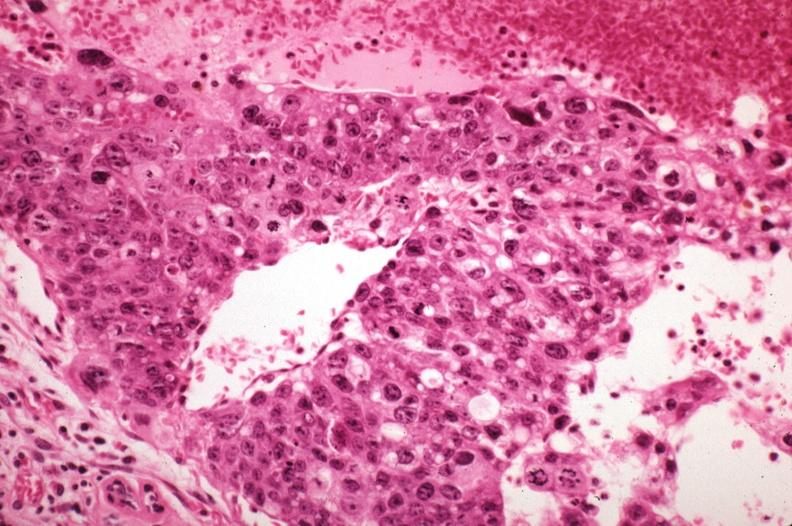s mitotic figures sickled red cells in vessels well shown?
Answer the question using a single word or phrase. Yes 